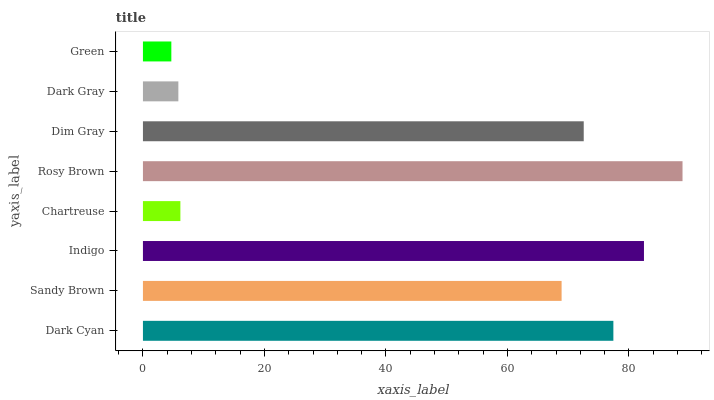Is Green the minimum?
Answer yes or no. Yes. Is Rosy Brown the maximum?
Answer yes or no. Yes. Is Sandy Brown the minimum?
Answer yes or no. No. Is Sandy Brown the maximum?
Answer yes or no. No. Is Dark Cyan greater than Sandy Brown?
Answer yes or no. Yes. Is Sandy Brown less than Dark Cyan?
Answer yes or no. Yes. Is Sandy Brown greater than Dark Cyan?
Answer yes or no. No. Is Dark Cyan less than Sandy Brown?
Answer yes or no. No. Is Dim Gray the high median?
Answer yes or no. Yes. Is Sandy Brown the low median?
Answer yes or no. Yes. Is Rosy Brown the high median?
Answer yes or no. No. Is Dim Gray the low median?
Answer yes or no. No. 